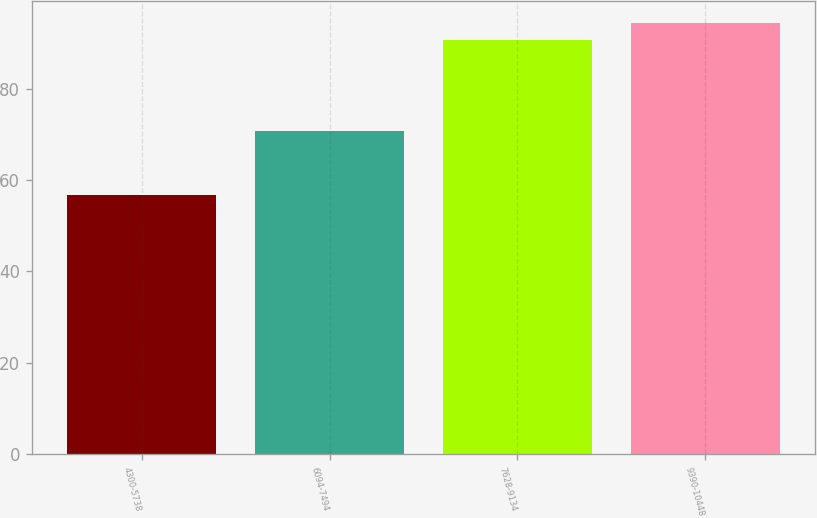Convert chart. <chart><loc_0><loc_0><loc_500><loc_500><bar_chart><fcel>4300-5738<fcel>6094-7494<fcel>7628-9134<fcel>9390-10448<nl><fcel>56.73<fcel>70.82<fcel>90.66<fcel>94.4<nl></chart> 